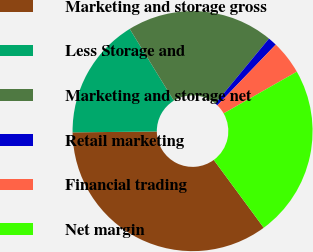Convert chart to OTSL. <chart><loc_0><loc_0><loc_500><loc_500><pie_chart><fcel>Marketing and storage gross<fcel>Less Storage and<fcel>Marketing and storage net<fcel>Retail marketing<fcel>Financial trading<fcel>Net margin<nl><fcel>34.94%<fcel>16.39%<fcel>19.76%<fcel>1.2%<fcel>4.57%<fcel>23.14%<nl></chart> 